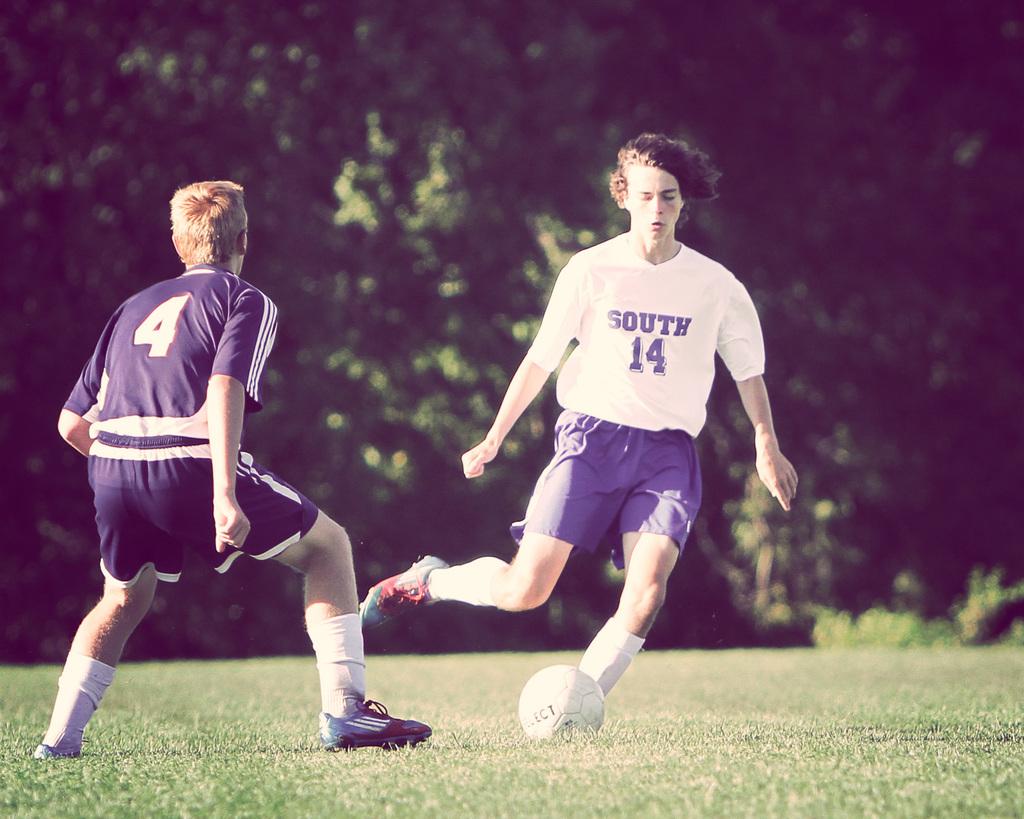What is the team number of the person kicking the ball?
Provide a short and direct response. 14. What is the number of the person in blue?
Offer a terse response. 4. 